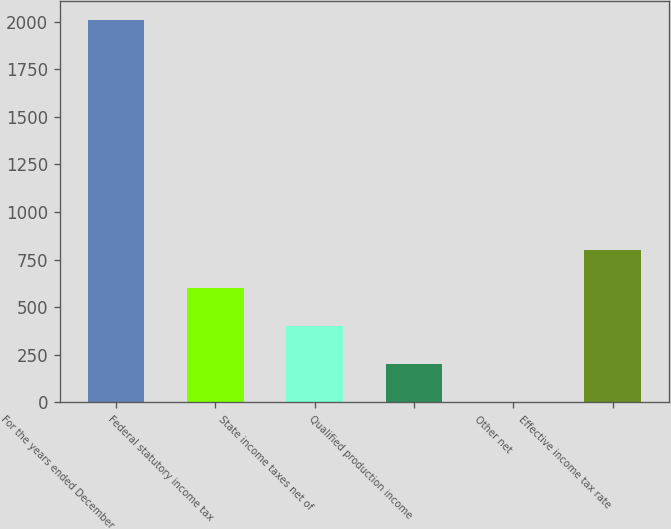Convert chart to OTSL. <chart><loc_0><loc_0><loc_500><loc_500><bar_chart><fcel>For the years ended December<fcel>Federal statutory income tax<fcel>State income taxes net of<fcel>Qualified production income<fcel>Other net<fcel>Effective income tax rate<nl><fcel>2007<fcel>602.45<fcel>401.8<fcel>201.15<fcel>0.5<fcel>803.1<nl></chart> 